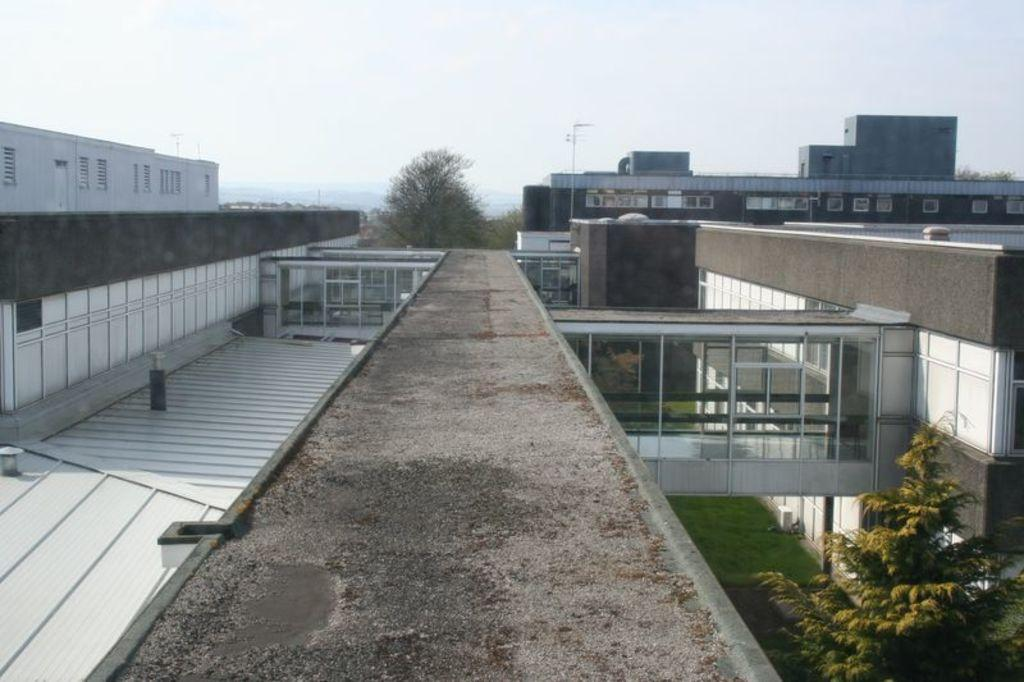What type of structures can be seen in the image? There are buildings in the image. What other natural elements are present in the image? There are trees in the image. What are the tall, thin objects in the image? There are poles in the image. What can be seen in the distance in the image? The sky is visible in the background of the image. What type of leather is used to make the poles in the image? There is no leather present in the image, as the poles are likely made of metal or another material. 